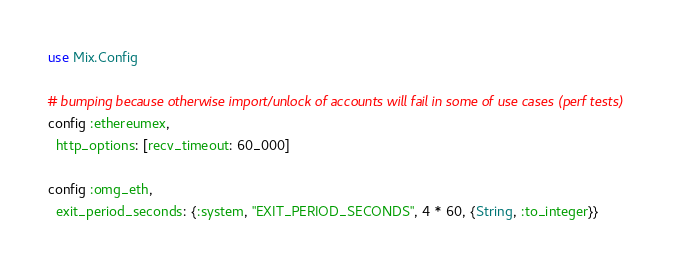<code> <loc_0><loc_0><loc_500><loc_500><_Elixir_>use Mix.Config

# bumping because otherwise import/unlock of accounts will fail in some of use cases (perf tests)
config :ethereumex,
  http_options: [recv_timeout: 60_000]

config :omg_eth,
  exit_period_seconds: {:system, "EXIT_PERIOD_SECONDS", 4 * 60, {String, :to_integer}}
</code> 